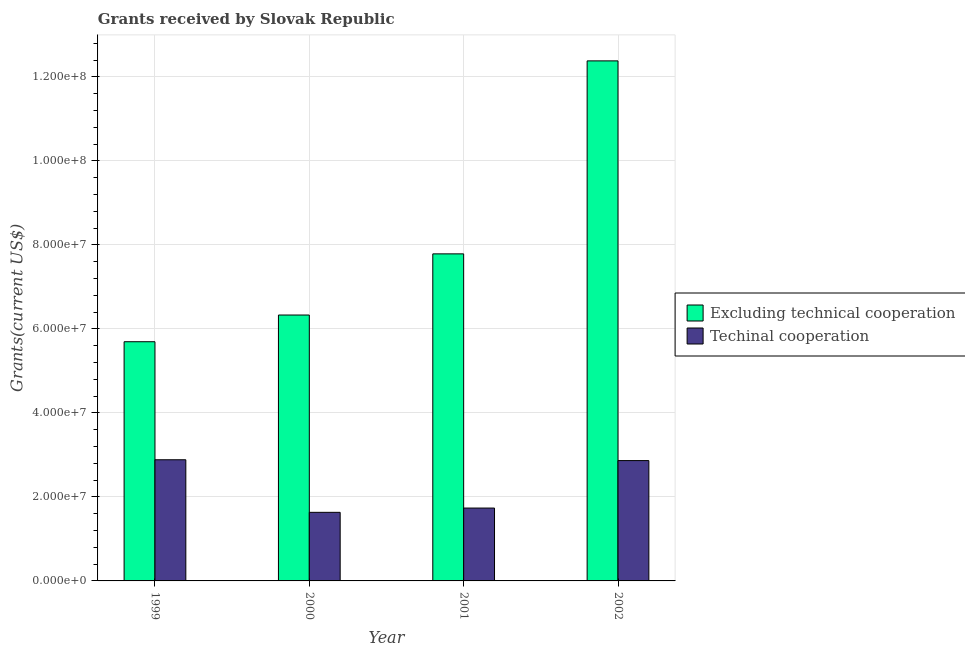How many different coloured bars are there?
Make the answer very short. 2. How many groups of bars are there?
Keep it short and to the point. 4. How many bars are there on the 3rd tick from the left?
Make the answer very short. 2. What is the label of the 2nd group of bars from the left?
Your answer should be compact. 2000. What is the amount of grants received(including technical cooperation) in 1999?
Offer a very short reply. 2.88e+07. Across all years, what is the maximum amount of grants received(excluding technical cooperation)?
Offer a very short reply. 1.24e+08. Across all years, what is the minimum amount of grants received(excluding technical cooperation)?
Provide a succinct answer. 5.70e+07. In which year was the amount of grants received(excluding technical cooperation) minimum?
Your answer should be compact. 1999. What is the total amount of grants received(excluding technical cooperation) in the graph?
Keep it short and to the point. 3.22e+08. What is the difference between the amount of grants received(including technical cooperation) in 2000 and that in 2002?
Make the answer very short. -1.23e+07. What is the difference between the amount of grants received(excluding technical cooperation) in 2001 and the amount of grants received(including technical cooperation) in 1999?
Provide a short and direct response. 2.09e+07. What is the average amount of grants received(including technical cooperation) per year?
Provide a short and direct response. 2.28e+07. In how many years, is the amount of grants received(including technical cooperation) greater than 112000000 US$?
Your answer should be very brief. 0. What is the ratio of the amount of grants received(including technical cooperation) in 2001 to that in 2002?
Keep it short and to the point. 0.61. Is the amount of grants received(including technical cooperation) in 1999 less than that in 2002?
Give a very brief answer. No. Is the difference between the amount of grants received(excluding technical cooperation) in 1999 and 2001 greater than the difference between the amount of grants received(including technical cooperation) in 1999 and 2001?
Make the answer very short. No. What is the difference between the highest and the second highest amount of grants received(excluding technical cooperation)?
Give a very brief answer. 4.60e+07. What is the difference between the highest and the lowest amount of grants received(excluding technical cooperation)?
Provide a short and direct response. 6.69e+07. Is the sum of the amount of grants received(excluding technical cooperation) in 2000 and 2002 greater than the maximum amount of grants received(including technical cooperation) across all years?
Keep it short and to the point. Yes. What does the 2nd bar from the left in 2001 represents?
Ensure brevity in your answer.  Techinal cooperation. What does the 2nd bar from the right in 1999 represents?
Your response must be concise. Excluding technical cooperation. How many years are there in the graph?
Provide a short and direct response. 4. Does the graph contain grids?
Make the answer very short. Yes. How are the legend labels stacked?
Keep it short and to the point. Vertical. What is the title of the graph?
Ensure brevity in your answer.  Grants received by Slovak Republic. What is the label or title of the Y-axis?
Offer a very short reply. Grants(current US$). What is the Grants(current US$) of Excluding technical cooperation in 1999?
Provide a succinct answer. 5.70e+07. What is the Grants(current US$) of Techinal cooperation in 1999?
Provide a short and direct response. 2.88e+07. What is the Grants(current US$) of Excluding technical cooperation in 2000?
Make the answer very short. 6.33e+07. What is the Grants(current US$) of Techinal cooperation in 2000?
Make the answer very short. 1.63e+07. What is the Grants(current US$) of Excluding technical cooperation in 2001?
Offer a terse response. 7.79e+07. What is the Grants(current US$) in Techinal cooperation in 2001?
Offer a very short reply. 1.74e+07. What is the Grants(current US$) in Excluding technical cooperation in 2002?
Ensure brevity in your answer.  1.24e+08. What is the Grants(current US$) of Techinal cooperation in 2002?
Make the answer very short. 2.86e+07. Across all years, what is the maximum Grants(current US$) in Excluding technical cooperation?
Provide a succinct answer. 1.24e+08. Across all years, what is the maximum Grants(current US$) in Techinal cooperation?
Ensure brevity in your answer.  2.88e+07. Across all years, what is the minimum Grants(current US$) of Excluding technical cooperation?
Provide a short and direct response. 5.70e+07. Across all years, what is the minimum Grants(current US$) in Techinal cooperation?
Your response must be concise. 1.63e+07. What is the total Grants(current US$) of Excluding technical cooperation in the graph?
Provide a succinct answer. 3.22e+08. What is the total Grants(current US$) of Techinal cooperation in the graph?
Keep it short and to the point. 9.12e+07. What is the difference between the Grants(current US$) in Excluding technical cooperation in 1999 and that in 2000?
Provide a short and direct response. -6.36e+06. What is the difference between the Grants(current US$) in Techinal cooperation in 1999 and that in 2000?
Make the answer very short. 1.25e+07. What is the difference between the Grants(current US$) of Excluding technical cooperation in 1999 and that in 2001?
Your response must be concise. -2.09e+07. What is the difference between the Grants(current US$) of Techinal cooperation in 1999 and that in 2001?
Make the answer very short. 1.15e+07. What is the difference between the Grants(current US$) of Excluding technical cooperation in 1999 and that in 2002?
Make the answer very short. -6.69e+07. What is the difference between the Grants(current US$) in Techinal cooperation in 1999 and that in 2002?
Provide a succinct answer. 2.00e+05. What is the difference between the Grants(current US$) in Excluding technical cooperation in 2000 and that in 2001?
Ensure brevity in your answer.  -1.46e+07. What is the difference between the Grants(current US$) of Techinal cooperation in 2000 and that in 2001?
Offer a terse response. -1.02e+06. What is the difference between the Grants(current US$) in Excluding technical cooperation in 2000 and that in 2002?
Your answer should be compact. -6.05e+07. What is the difference between the Grants(current US$) in Techinal cooperation in 2000 and that in 2002?
Offer a very short reply. -1.23e+07. What is the difference between the Grants(current US$) of Excluding technical cooperation in 2001 and that in 2002?
Give a very brief answer. -4.60e+07. What is the difference between the Grants(current US$) of Techinal cooperation in 2001 and that in 2002?
Offer a terse response. -1.13e+07. What is the difference between the Grants(current US$) in Excluding technical cooperation in 1999 and the Grants(current US$) in Techinal cooperation in 2000?
Provide a succinct answer. 4.06e+07. What is the difference between the Grants(current US$) in Excluding technical cooperation in 1999 and the Grants(current US$) in Techinal cooperation in 2001?
Your answer should be compact. 3.96e+07. What is the difference between the Grants(current US$) in Excluding technical cooperation in 1999 and the Grants(current US$) in Techinal cooperation in 2002?
Ensure brevity in your answer.  2.83e+07. What is the difference between the Grants(current US$) in Excluding technical cooperation in 2000 and the Grants(current US$) in Techinal cooperation in 2001?
Provide a short and direct response. 4.60e+07. What is the difference between the Grants(current US$) of Excluding technical cooperation in 2000 and the Grants(current US$) of Techinal cooperation in 2002?
Offer a terse response. 3.47e+07. What is the difference between the Grants(current US$) in Excluding technical cooperation in 2001 and the Grants(current US$) in Techinal cooperation in 2002?
Provide a succinct answer. 4.92e+07. What is the average Grants(current US$) in Excluding technical cooperation per year?
Provide a succinct answer. 8.05e+07. What is the average Grants(current US$) of Techinal cooperation per year?
Provide a short and direct response. 2.28e+07. In the year 1999, what is the difference between the Grants(current US$) in Excluding technical cooperation and Grants(current US$) in Techinal cooperation?
Make the answer very short. 2.81e+07. In the year 2000, what is the difference between the Grants(current US$) in Excluding technical cooperation and Grants(current US$) in Techinal cooperation?
Offer a terse response. 4.70e+07. In the year 2001, what is the difference between the Grants(current US$) of Excluding technical cooperation and Grants(current US$) of Techinal cooperation?
Offer a terse response. 6.05e+07. In the year 2002, what is the difference between the Grants(current US$) in Excluding technical cooperation and Grants(current US$) in Techinal cooperation?
Offer a terse response. 9.52e+07. What is the ratio of the Grants(current US$) in Excluding technical cooperation in 1999 to that in 2000?
Keep it short and to the point. 0.9. What is the ratio of the Grants(current US$) of Techinal cooperation in 1999 to that in 2000?
Provide a succinct answer. 1.77. What is the ratio of the Grants(current US$) in Excluding technical cooperation in 1999 to that in 2001?
Your answer should be very brief. 0.73. What is the ratio of the Grants(current US$) in Techinal cooperation in 1999 to that in 2001?
Your answer should be very brief. 1.66. What is the ratio of the Grants(current US$) in Excluding technical cooperation in 1999 to that in 2002?
Your answer should be very brief. 0.46. What is the ratio of the Grants(current US$) in Techinal cooperation in 1999 to that in 2002?
Make the answer very short. 1.01. What is the ratio of the Grants(current US$) of Excluding technical cooperation in 2000 to that in 2001?
Offer a terse response. 0.81. What is the ratio of the Grants(current US$) of Excluding technical cooperation in 2000 to that in 2002?
Keep it short and to the point. 0.51. What is the ratio of the Grants(current US$) in Techinal cooperation in 2000 to that in 2002?
Your response must be concise. 0.57. What is the ratio of the Grants(current US$) of Excluding technical cooperation in 2001 to that in 2002?
Give a very brief answer. 0.63. What is the ratio of the Grants(current US$) of Techinal cooperation in 2001 to that in 2002?
Offer a terse response. 0.61. What is the difference between the highest and the second highest Grants(current US$) of Excluding technical cooperation?
Your response must be concise. 4.60e+07. What is the difference between the highest and the second highest Grants(current US$) in Techinal cooperation?
Keep it short and to the point. 2.00e+05. What is the difference between the highest and the lowest Grants(current US$) in Excluding technical cooperation?
Your answer should be very brief. 6.69e+07. What is the difference between the highest and the lowest Grants(current US$) in Techinal cooperation?
Provide a succinct answer. 1.25e+07. 